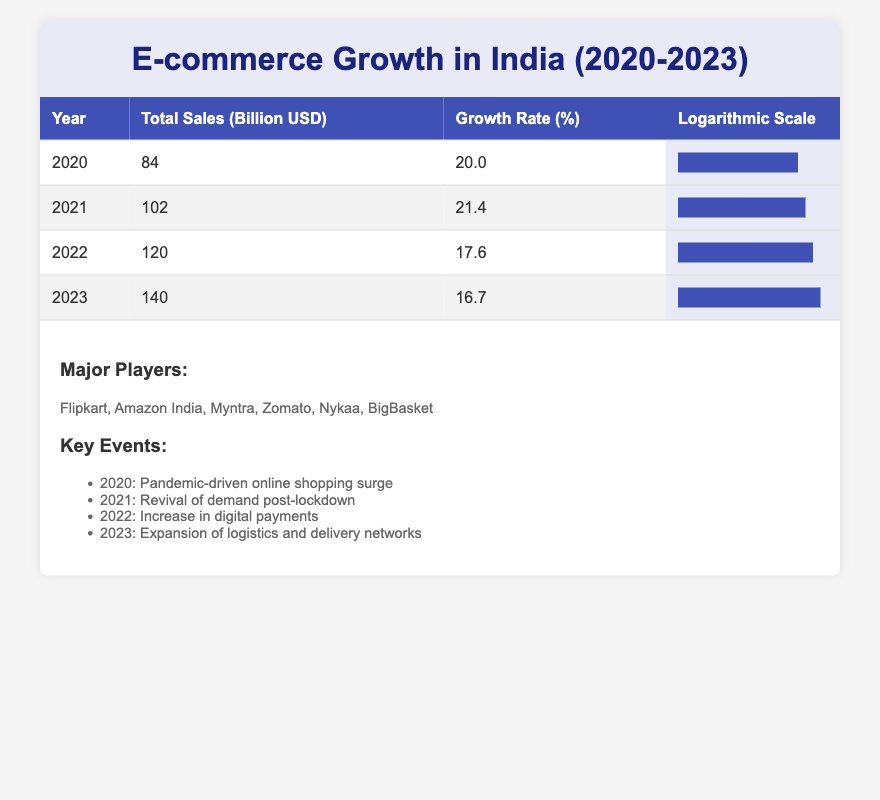What was the total e-commerce sales in India in 2020? According to the table, the total sales figure for the year 2020 is listed directly under the "Total Sales (Billion USD)" column, which states 84 billion USD.
Answer: 84 billion USD Which year saw the highest growth rate? From the growth rates listed for each year, 2021 has the highest growth rate of 21.4% compared to the growth rates of 20.0%, 17.6%, and 16.7% for 2020, 2022, and 2023 respectively.
Answer: 2021 What is the average total sales from 2020 to 2023? First, we calculate the total sales: 84 + 102 + 120 + 140 = 446 billion USD. Then, divide by the number of years, which is 4: 446 / 4 = 111.5 billion USD.
Answer: 111.5 billion USD Did e-commerce sales increase every year from 2020 to 2023? By comparing the total sales figures, we see that 2020 to 2021 sales increased from 84 to 102 billion, 2021 to 2022 from 102 to 120 billion, and finally from 2022 to 2023 sales increased from 120 to 140 billion. Therefore, sales increased every year.
Answer: Yes What was the total growth rate over the four years? To find the total growth, we determine the growth from 2020 to 2023: from 84 billion USD in 2020 to 140 billion USD in 2023, which is 140 - 84 = 56 billion USD. To find the growth rate, it's calculated as (56 / 84) * 100 = 66.67%.
Answer: 66.67% 